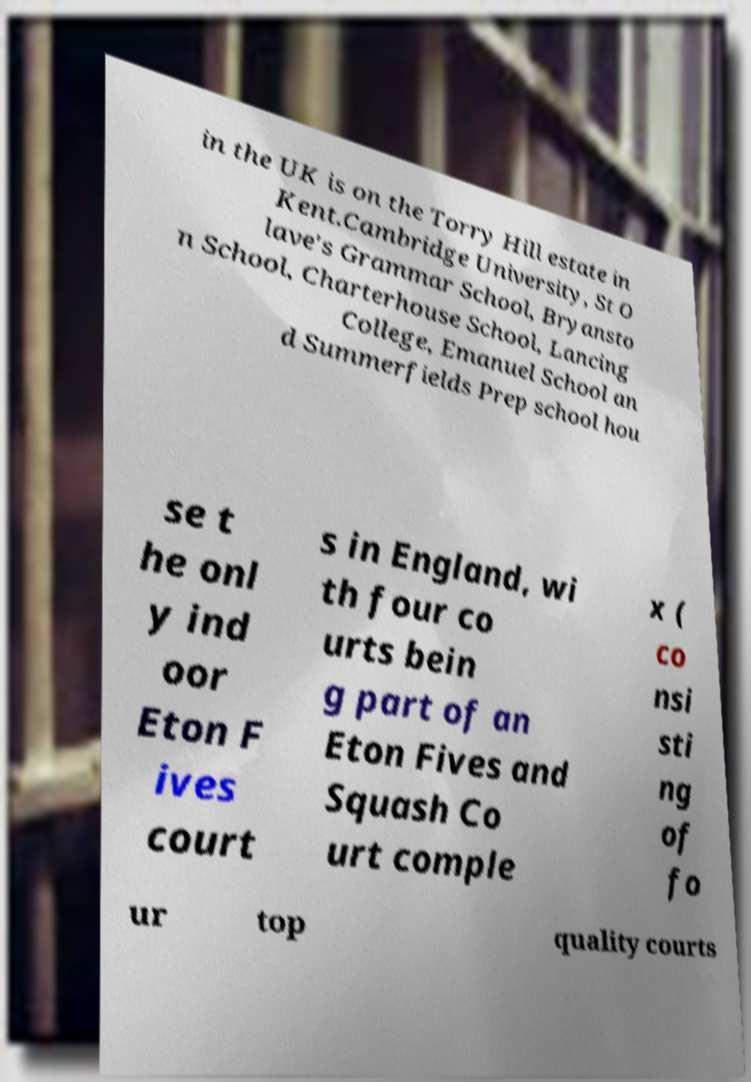I need the written content from this picture converted into text. Can you do that? in the UK is on the Torry Hill estate in Kent.Cambridge University, St O lave's Grammar School, Bryansto n School, Charterhouse School, Lancing College, Emanuel School an d Summerfields Prep school hou se t he onl y ind oor Eton F ives court s in England, wi th four co urts bein g part of an Eton Fives and Squash Co urt comple x ( co nsi sti ng of fo ur top quality courts 